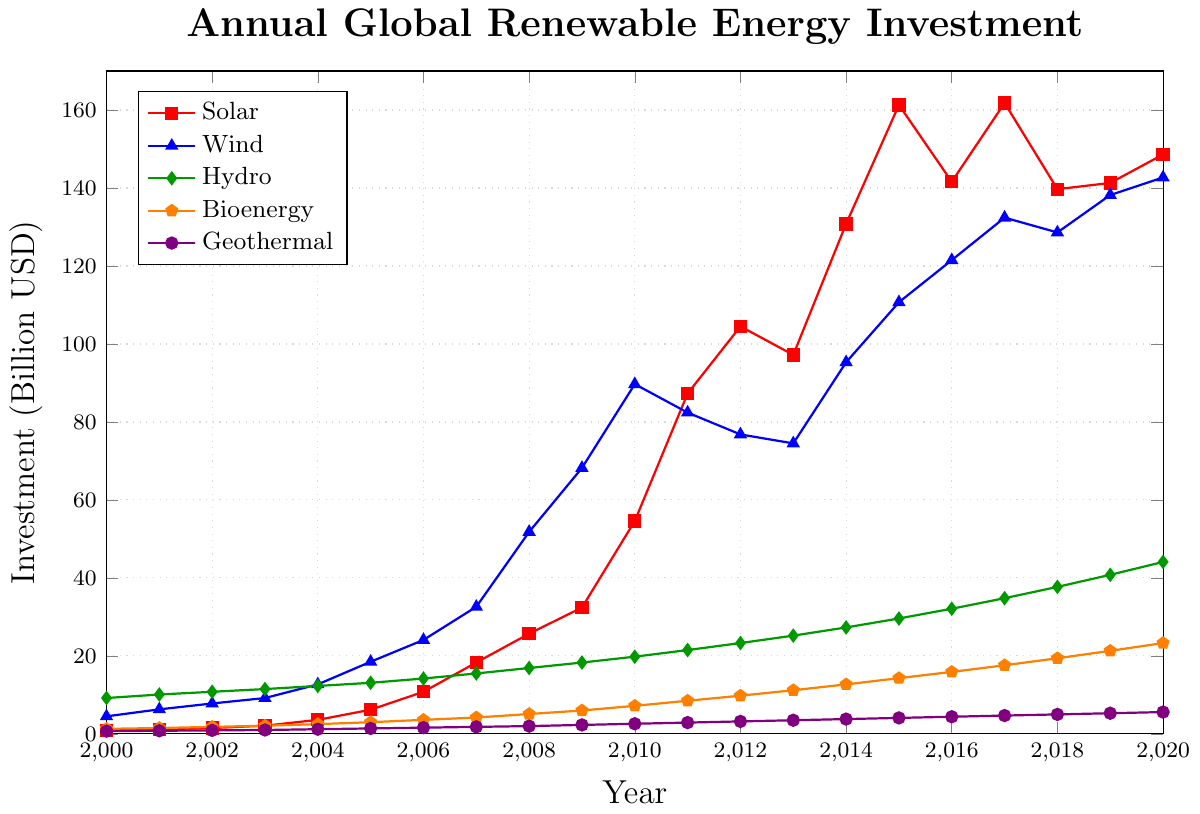What is the total investment in renewable energy for the year 2005? To find the total investment for 2005, sum up the investments in Solar, Wind, Hydro, Bioenergy, and Geothermal for that year. These values are: 6.2 (Solar), 18.5 (Wind), 13.1 (Hydro), 3.0 (Bioenergy), 1.4 (Geothermal). Adding these, we get 6.2 + 18.5 + 13.1 + 3.0 + 1.4 = 42.2 billion USD.
Answer: 42.2 Which energy type had the highest investment in 2010? From the plot, observe the height of each line at the year 2010. The investments are Solar: 54.6, Wind: 89.7, Hydro: 19.8, Bioenergy: 7.2, Geothermal: 2.6. Wind has the highest investment at 89.7 billion USD.
Answer: Wind How much did the investment in Solar energy increase from 2000 to 2020? Subtract the Solar investment in 2000 from that in 2020. In 2000, the investment was 0.8 billion USD, and in 2020, it was 148.6 billion USD. Thus, the increase is 148.6 - 0.8 = 147.8 billion USD.
Answer: 147.8 Compare the investments in Hydro and Bioenergy in 2015. Which one is higher, and by how much? For 2015, identify the investments from the plot: Hydro: 29.6, Bioenergy: 14.3. Hydro investment is higher. To find the difference, subtract the Bioenergy investment from the Hydro investment: 29.6 - 14.3 = 15.3 billion USD.
Answer: Hydro, 15.3 What is the average annual investment in Wind energy from 2000 to 2010? To find the average, sum the annual investments in Wind from 2000 to 2010 and divide by the number of years. The investments are: 4.5, 6.3, 7.8, 9.2, 12.7, 18.5, 24.1, 32.6, 51.8, 68.2, 89.7. Summing these, we get 325.4. Dividing by 11 years, the average is 325.4 / 11 ≈ 29.58 billion USD.
Answer: 29.58 What is the percentage growth in Bioenergy investment from 2000 to 2020? First, find the initial and final investments in Bioenergy: 2000: 1.3 billion USD, 2020: 23.3 billion USD. Calculate the growth using the formula: ((Final - Initial) / Initial) * 100. Plugging in the values, ((23.3 - 1.3) / 1.3) * 100 ≈ 1692.3%.
Answer: 1692.3 Which energy type showed the most consistent year-on-year
increase in investment from 2000 to 2020? To answer this, observe the smoothness and rising trend of the lines in the plot. Both Solar and Hydro show consistent increases, but Hydro's line is the smoothest and steadiest increase over the years.
Answer: Hydro What is the combined investment in Solar and Wind energy in 2020? Add the investments in Solar and Wind for 2020. Solar: 148.6, Wind: 142.7. The combined investment is 148.6 + 142.7 = 291.3 billion USD.
Answer: 291.3 In which year did Solar investment surpass Wind investment? Compare Solar and Wind lines each year, starting from where Solar is lower, until Solar exceeds Wind. By inspection, this occurs between 2015 and 2016, as 2015 Solar: 161.3, Wind: 110.7, Solar surpasses here.
Answer: 2015 